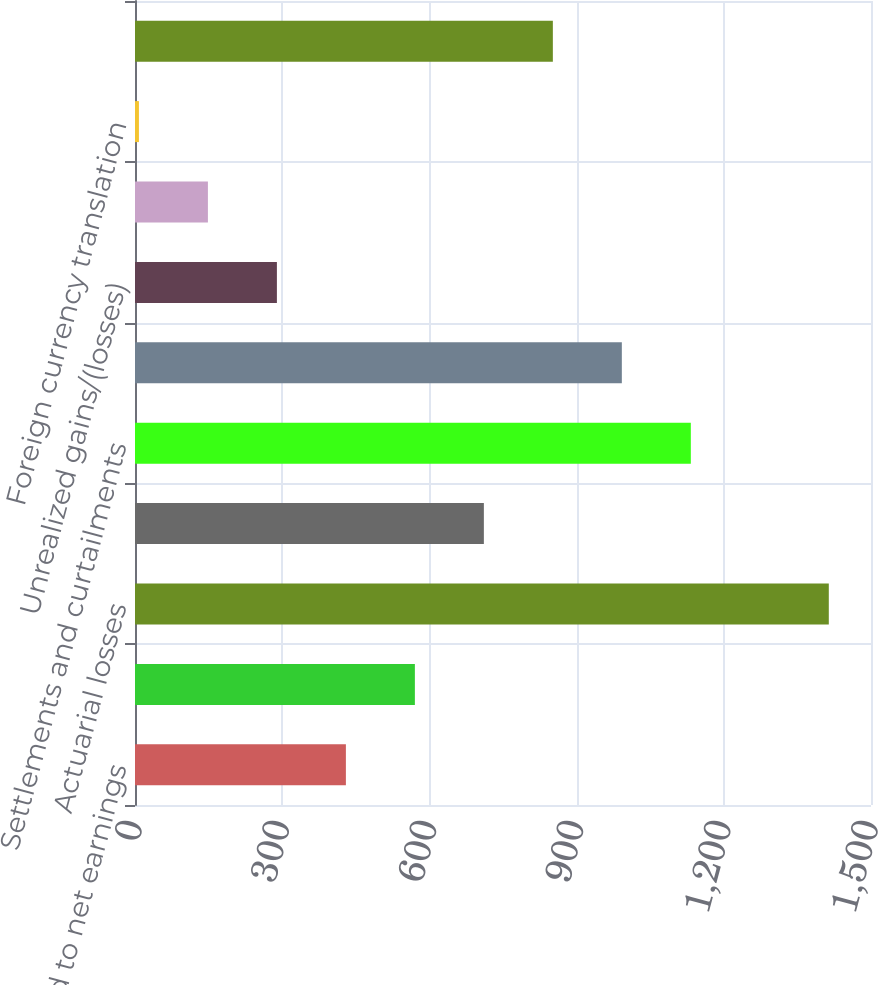Convert chart to OTSL. <chart><loc_0><loc_0><loc_500><loc_500><bar_chart><fcel>Reclassified to net earnings<fcel>Derivatives qualifying as cash<fcel>Actuarial losses<fcel>Amortization (b)<fcel>Settlements and curtailments<fcel>Pension and other<fcel>Unrealized gains/(losses)<fcel>Available-for-sale securities<fcel>Foreign currency translation<fcel>Total Other Comprehensive<nl><fcel>429.8<fcel>570.4<fcel>1414<fcel>711<fcel>1132.8<fcel>992.2<fcel>289.2<fcel>148.6<fcel>8<fcel>851.6<nl></chart> 